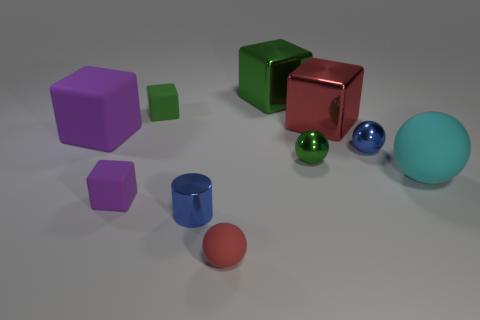There is a small cube on the right side of the tiny object to the left of the green matte cube; is there a green block behind it?
Keep it short and to the point. Yes. There is a large red thing that is the same shape as the green rubber thing; what is its material?
Give a very brief answer. Metal. There is a green object that is in front of the green matte cube; how many large metallic blocks are left of it?
Make the answer very short. 1. How big is the blue object on the right side of the shiny cube that is right of the green block right of the small red matte object?
Offer a very short reply. Small. The rubber ball that is behind the tiny blue thing in front of the blue ball is what color?
Provide a succinct answer. Cyan. How many other things are there of the same material as the cyan sphere?
Provide a short and direct response. 4. How many other objects are there of the same color as the large ball?
Make the answer very short. 0. The cube left of the tiny matte object left of the tiny green rubber block is made of what material?
Provide a succinct answer. Rubber. Is there a large red object?
Ensure brevity in your answer.  Yes. How big is the thing that is right of the blue metal thing behind the green sphere?
Your response must be concise. Large. 